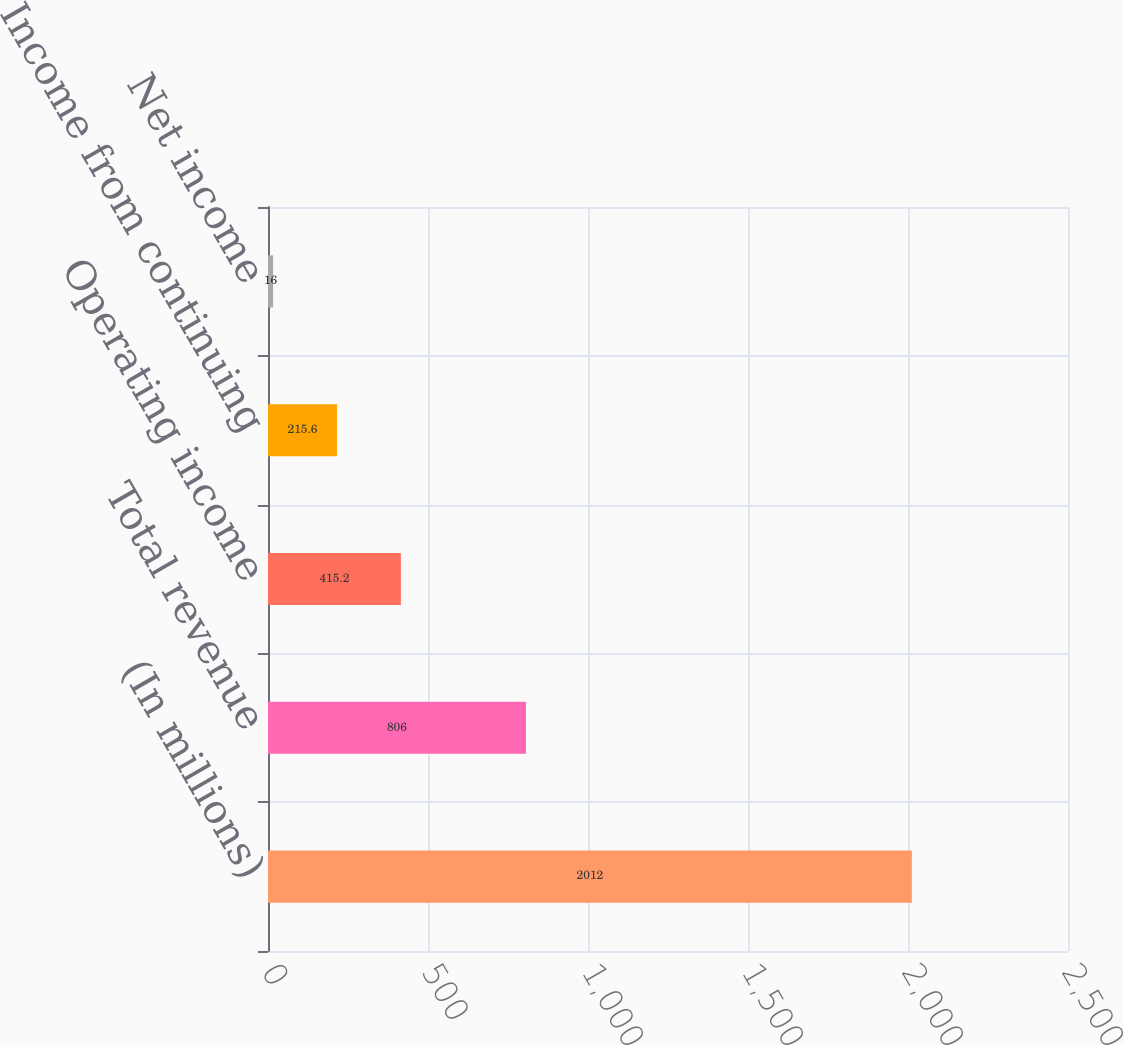Convert chart. <chart><loc_0><loc_0><loc_500><loc_500><bar_chart><fcel>(In millions)<fcel>Total revenue<fcel>Operating income<fcel>Income from continuing<fcel>Net income<nl><fcel>2012<fcel>806<fcel>415.2<fcel>215.6<fcel>16<nl></chart> 